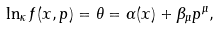<formula> <loc_0><loc_0><loc_500><loc_500>\ln _ { \kappa } f ( x , p ) = \theta = \alpha ( x ) + \beta _ { \mu } p ^ { \mu } ,</formula> 